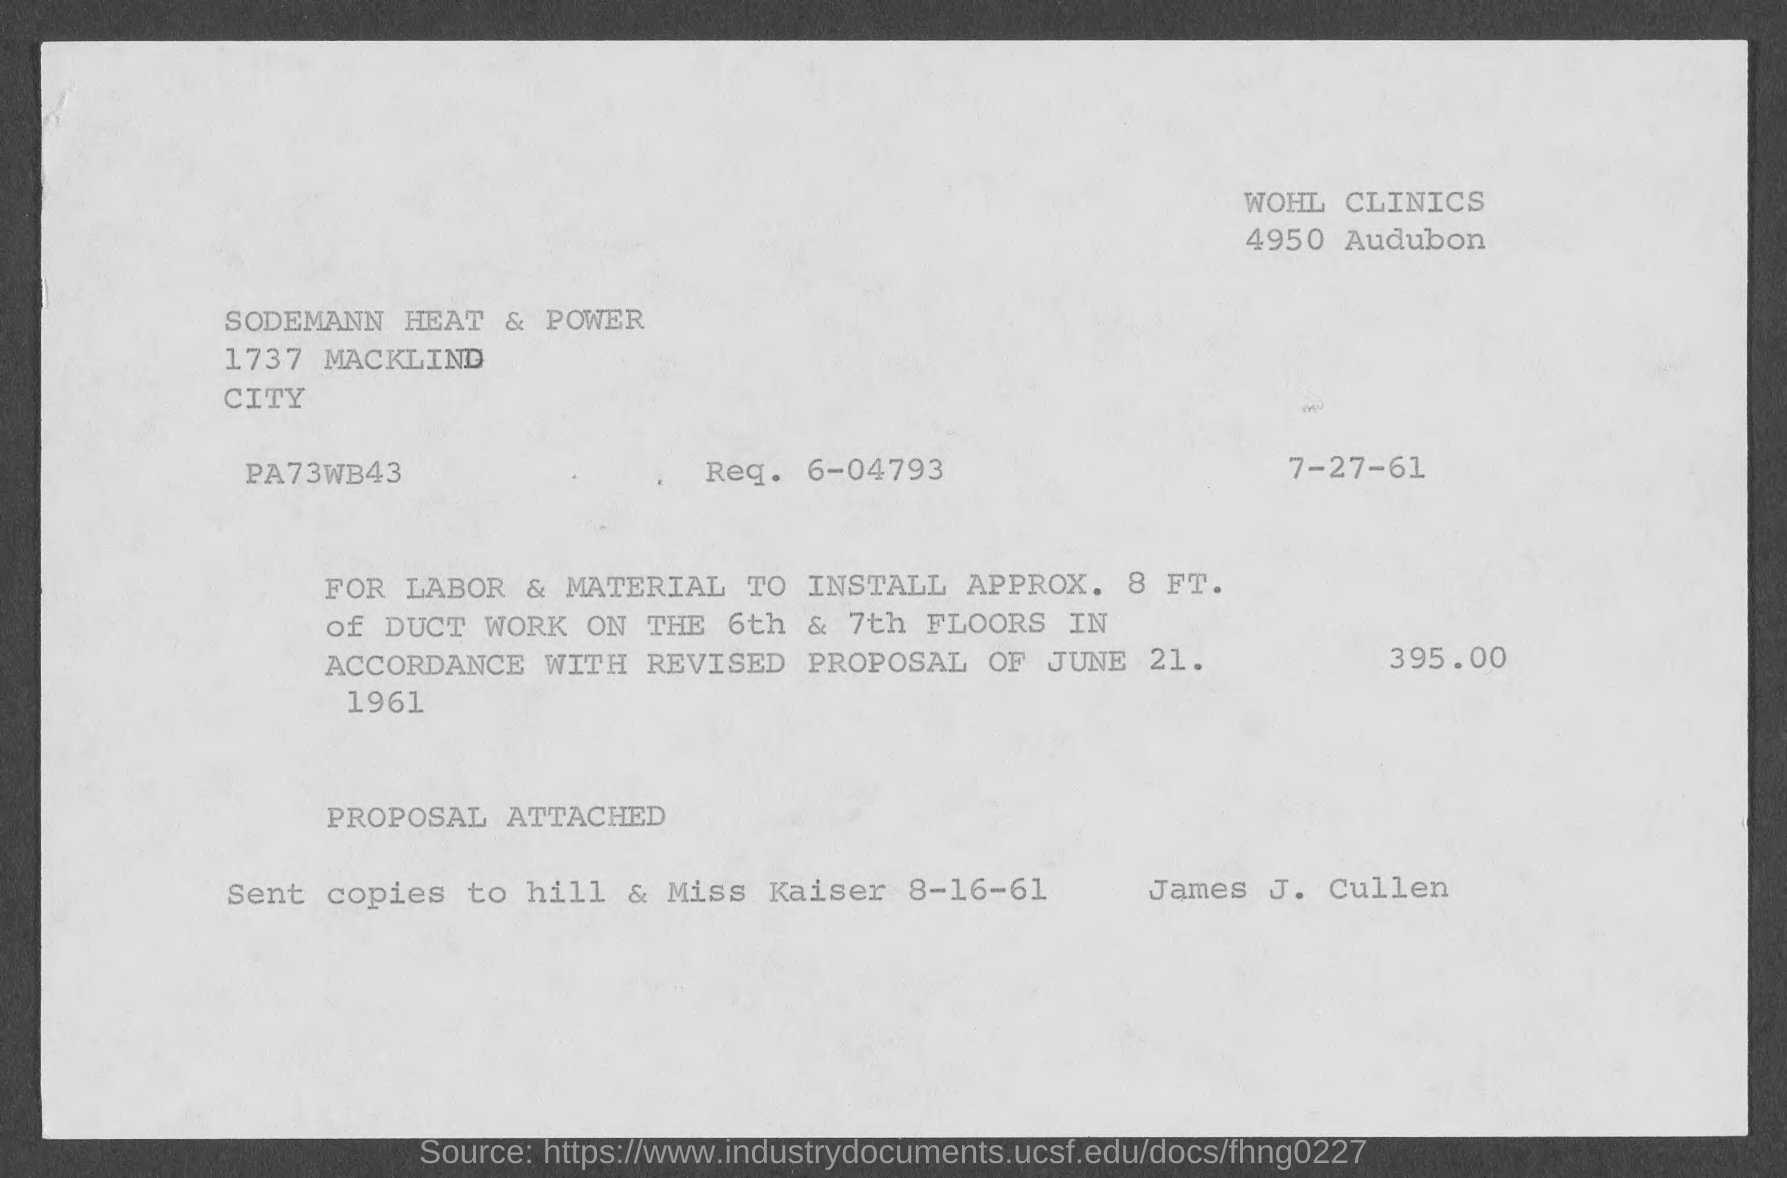Identify some key points in this picture. The request number is 6-04793. 